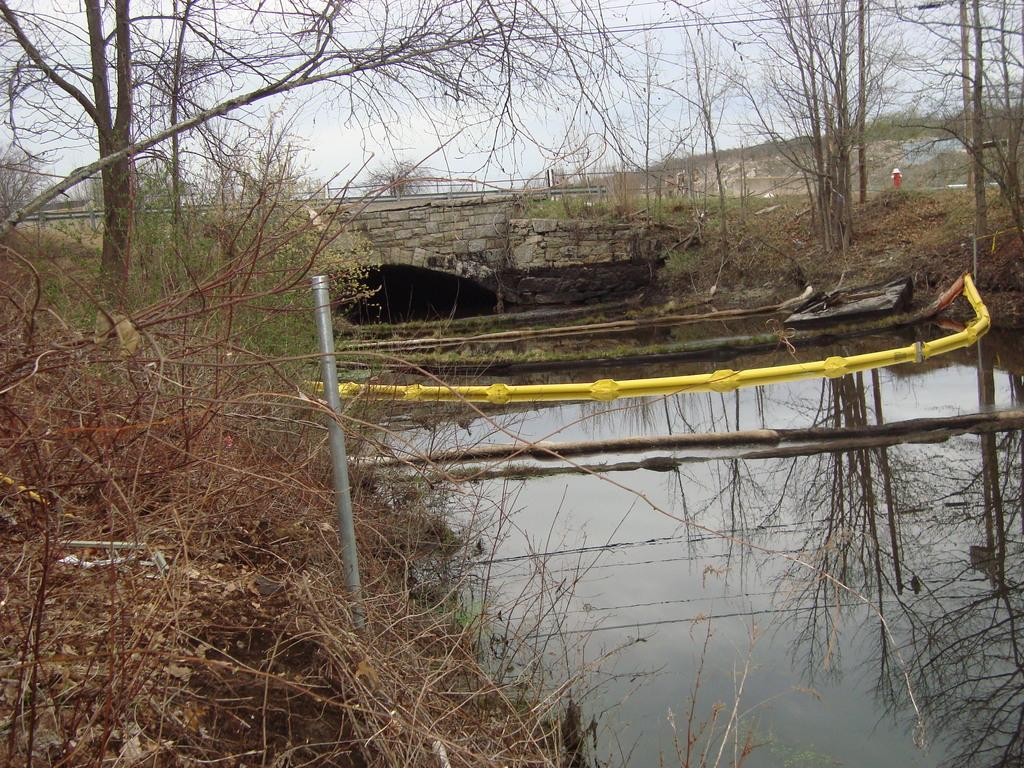What structure can be seen in the image? There is a bridge in the image. What is the bridge positioned over? The bridge is over water. What type of vegetation is present in the image? There are plants and trees in the image. What are the poles and wooden sticks used for in the image? The poles and wooden sticks are likely used for supporting the bridge or wires. What else can be seen in the image besides the bridge and vegetation? There are wires and the sky visible in the image. What idea does the alarm have for the run in the image? There is no alarm or run present in the image; it features a bridge over water with plants, trees, poles, wooden sticks, wires, and the sky. 